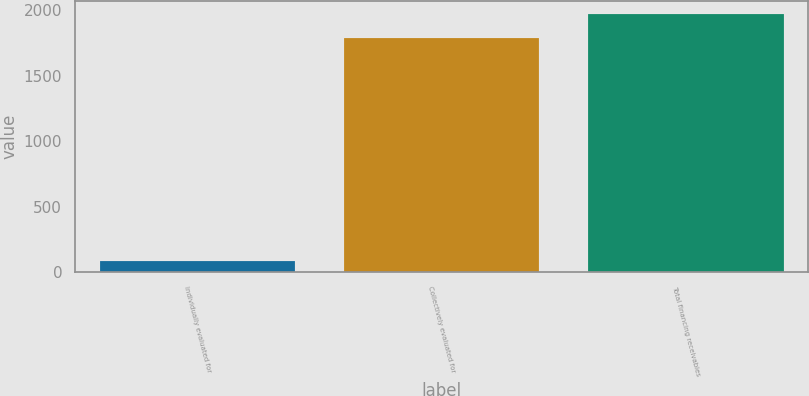<chart> <loc_0><loc_0><loc_500><loc_500><bar_chart><fcel>Individually evaluated for<fcel>Collectively evaluated for<fcel>Total financing receivables<nl><fcel>86<fcel>1790<fcel>1969<nl></chart> 